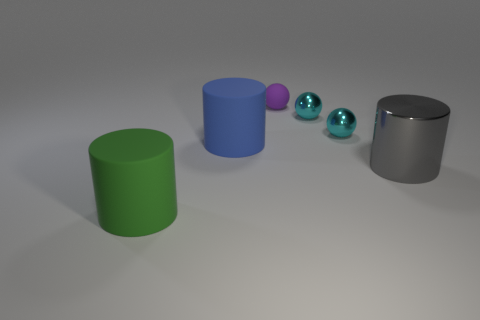Subtract all cyan shiny balls. How many balls are left? 1 Subtract all blue cylinders. How many cylinders are left? 2 Subtract 2 cylinders. How many cylinders are left? 1 Add 3 gray metallic cylinders. How many objects exist? 9 Subtract all green cubes. How many purple balls are left? 1 Subtract all cyan balls. Subtract all gray cubes. How many balls are left? 1 Add 5 big cylinders. How many big cylinders are left? 8 Add 6 tiny cyan spheres. How many tiny cyan spheres exist? 8 Subtract 0 yellow cylinders. How many objects are left? 6 Subtract all large cylinders. Subtract all small spheres. How many objects are left? 0 